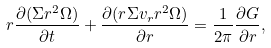Convert formula to latex. <formula><loc_0><loc_0><loc_500><loc_500>r \frac { { \partial } ( \Sigma r ^ { 2 } \Omega ) } { { \partial } t } + \frac { { \partial } ( r \Sigma v _ { r } r ^ { 2 } \Omega ) } { \partial r } = \frac { 1 } { 2 \pi } \frac { { \partial } G } { { \partial } r } ,</formula> 